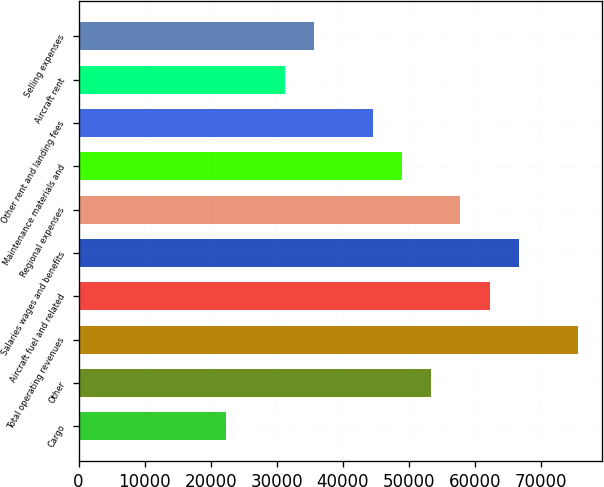Convert chart to OTSL. <chart><loc_0><loc_0><loc_500><loc_500><bar_chart><fcel>Cargo<fcel>Other<fcel>Total operating revenues<fcel>Aircraft fuel and related<fcel>Salaries wages and benefits<fcel>Regional expenses<fcel>Maintenance materials and<fcel>Other rent and landing fees<fcel>Aircraft rent<fcel>Selling expenses<nl><fcel>22348.5<fcel>53402.6<fcel>75584.1<fcel>62275.2<fcel>66711.5<fcel>57838.9<fcel>48966.3<fcel>44530<fcel>31221.1<fcel>35657.4<nl></chart> 